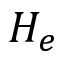Convert formula to latex. <formula><loc_0><loc_0><loc_500><loc_500>H _ { e }</formula> 